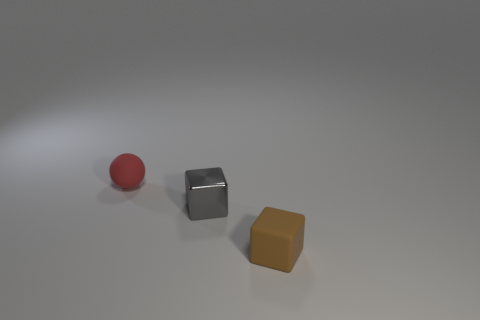Does the metallic thing have the same color as the tiny sphere?
Your answer should be very brief. No. Are there fewer small red things that are behind the small gray metal object than tiny brown matte things?
Offer a terse response. No. Does the gray object have the same material as the tiny red object that is behind the small brown rubber thing?
Ensure brevity in your answer.  No. What is the gray thing made of?
Provide a succinct answer. Metal. What material is the tiny cube that is in front of the cube that is behind the cube that is in front of the small metal block made of?
Keep it short and to the point. Rubber. There is a shiny object; is it the same color as the small rubber object behind the small brown rubber object?
Ensure brevity in your answer.  No. Is there anything else that is the same shape as the small red object?
Provide a short and direct response. No. There is a matte thing that is right of the tiny object that is behind the small gray block; what is its color?
Keep it short and to the point. Brown. How many red matte balls are there?
Your answer should be compact. 1. How many metal things are either purple cylinders or tiny red spheres?
Offer a terse response. 0. 